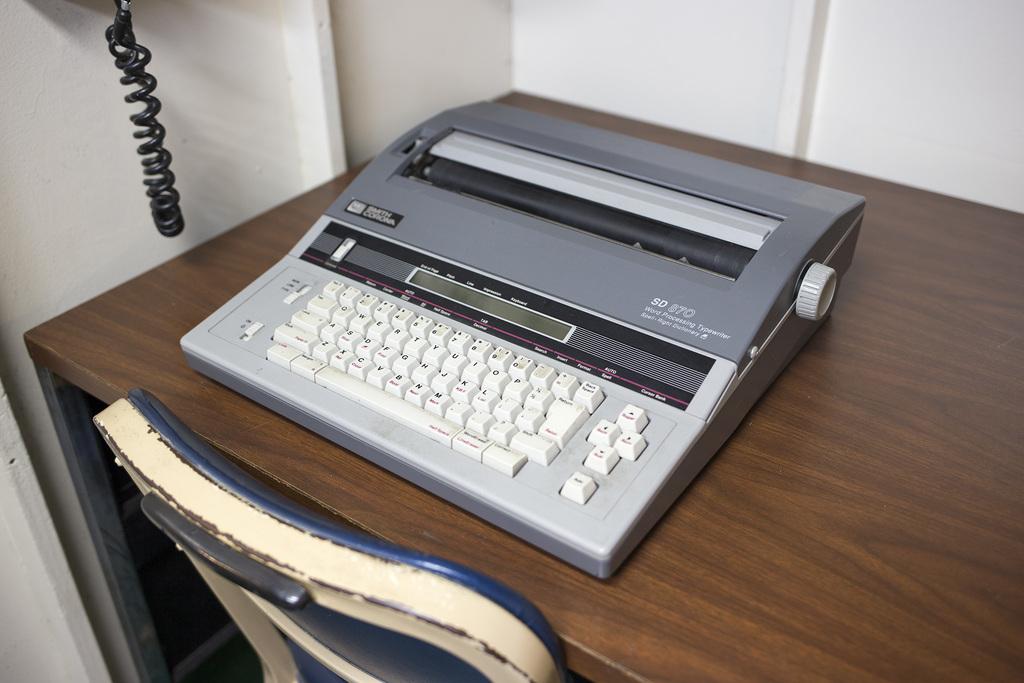What is the make of this typewriter?
Provide a succinct answer. Smith corona. What model is this typewriter?
Your answer should be compact. Sd 870. 